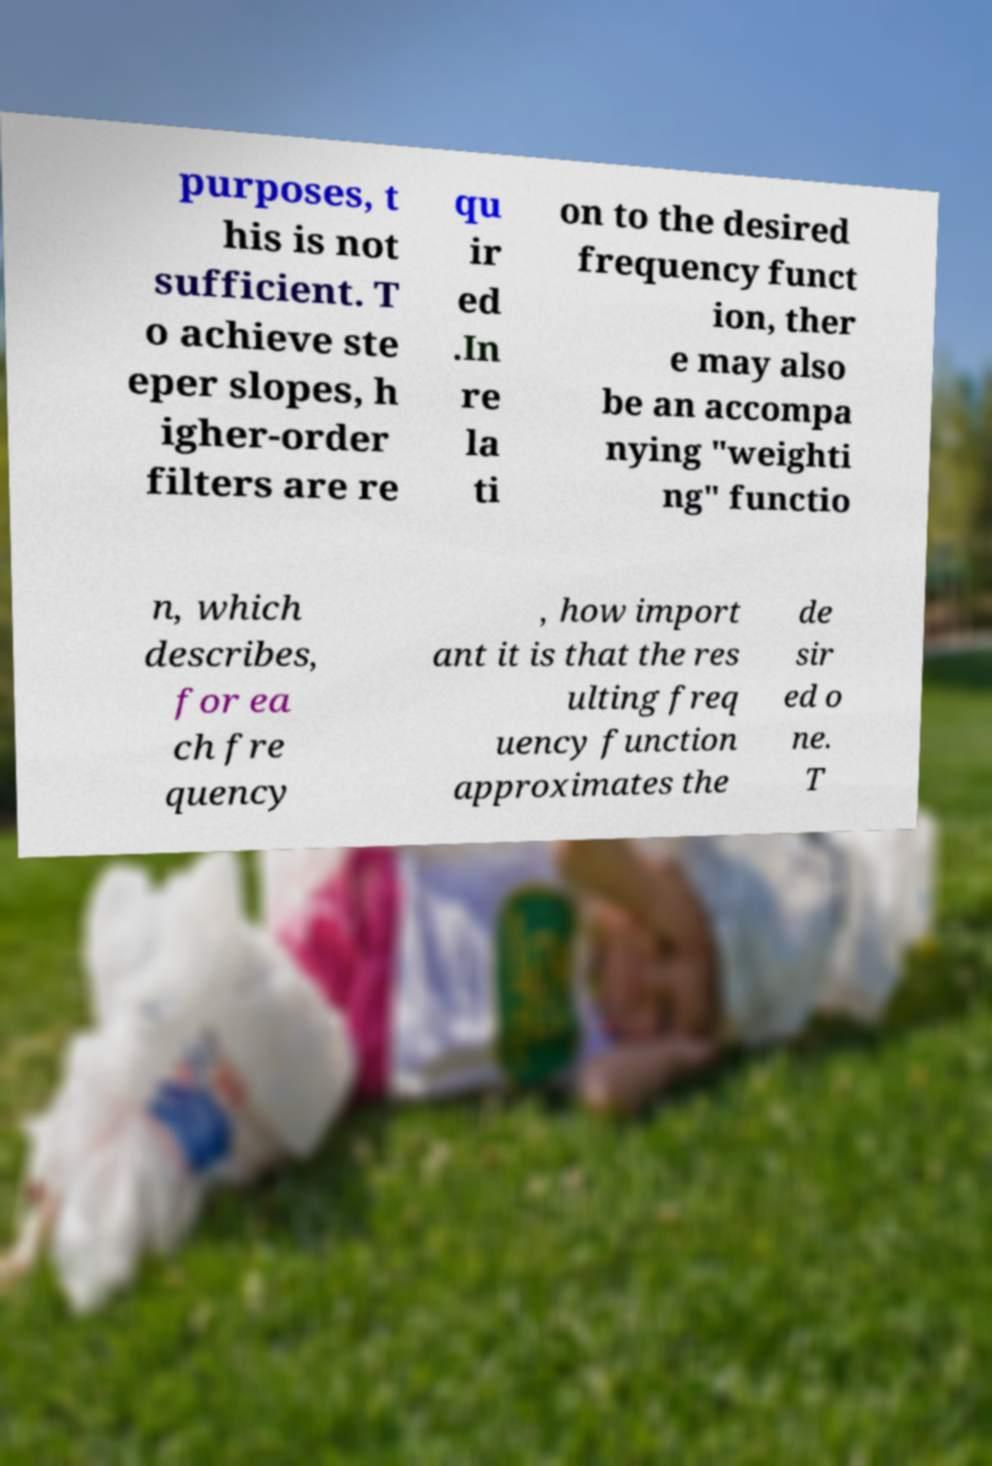I need the written content from this picture converted into text. Can you do that? purposes, t his is not sufficient. T o achieve ste eper slopes, h igher-order filters are re qu ir ed .In re la ti on to the desired frequency funct ion, ther e may also be an accompa nying "weighti ng" functio n, which describes, for ea ch fre quency , how import ant it is that the res ulting freq uency function approximates the de sir ed o ne. T 